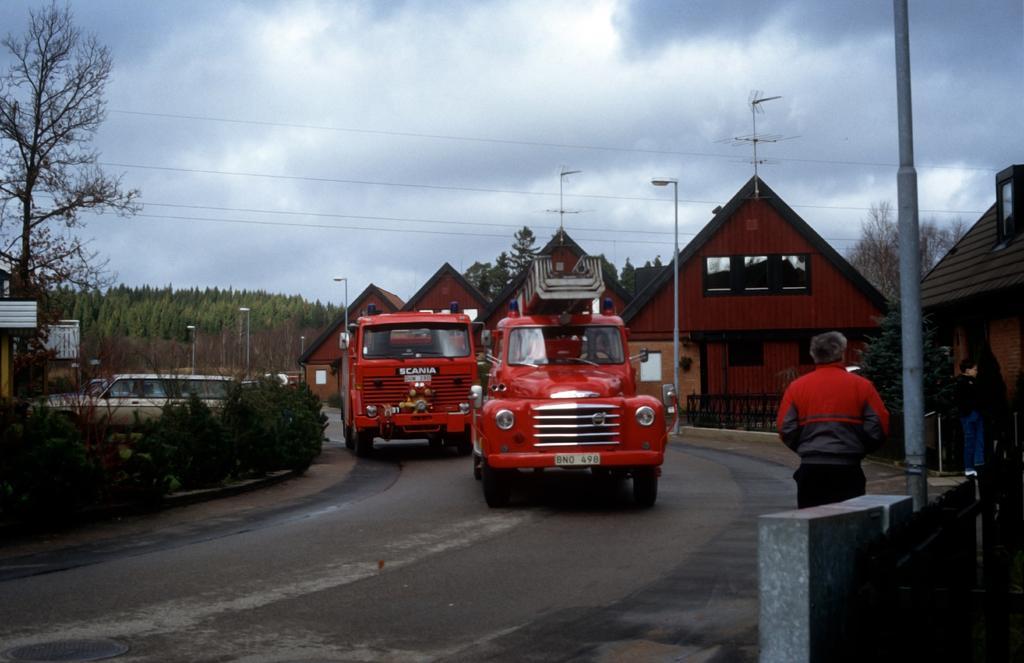In one or two sentences, can you explain what this image depicts? In this picture we can see two vehicles in the middle, on the left side there are some plants, trees and poles, there is a person standing in the front, on the right side there are some houses and pole, we can see the sky at the top of the picture. 